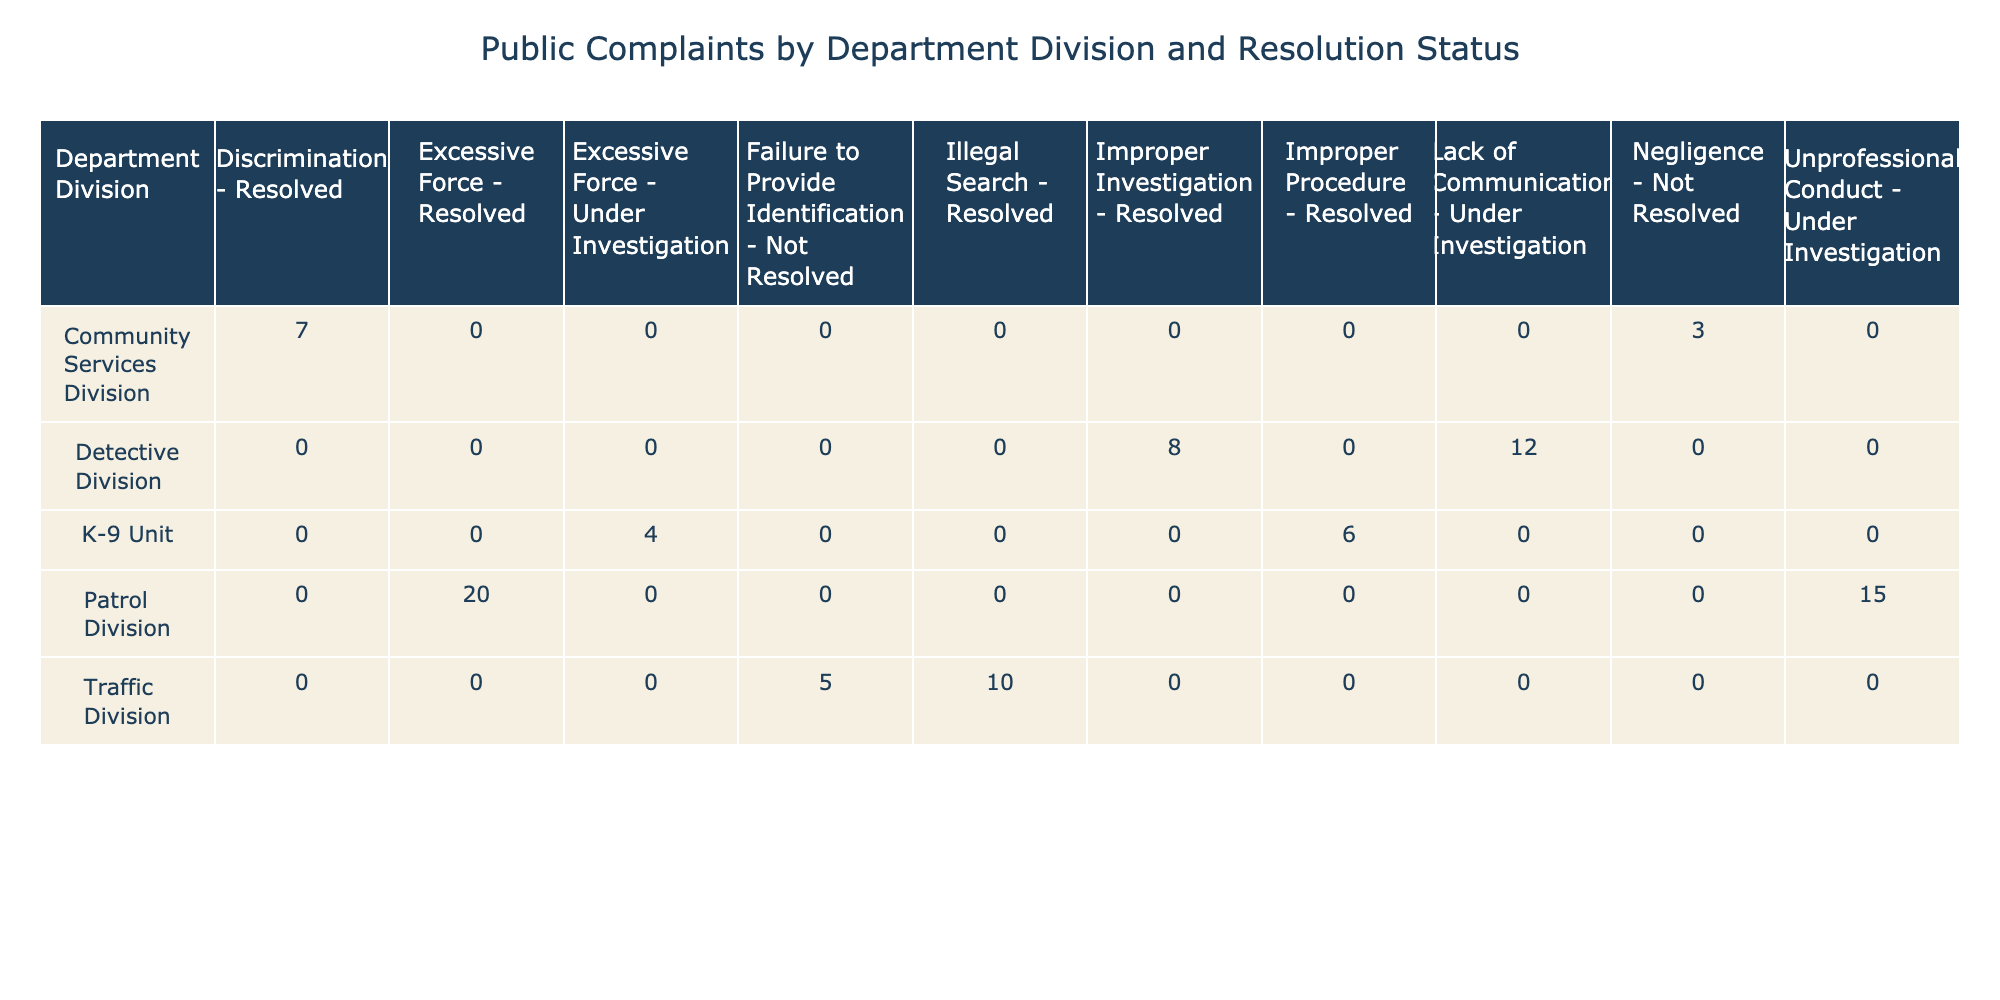What is the total number of resolved complaints in the Patrol Division? There are two categories in the Patrol Division: Excessive Force with 20 resolved complaints and Unprofessional Conduct which is under investigation. Thus, the total number of resolved complaints is 20.
Answer: 20 How many complaints in the Traffic Division are categorized as "Not Resolved"? In the Traffic Division, there is one complaint categorized as "Not Resolved" which is "Failure to Provide Identification," with a count of 5.
Answer: 5 Is there any complaint in the Community Services Division that is "Under Investigation"? The Community Services Division has two complaints: "Discrimination" is resolved, and "Negligence" is not resolved. Therefore, there are no complaints under investigation in this division.
Answer: No What is the sum of all complaints received by the K-9 Unit? The K-9 Unit has two complaints: Excessive Force with 4 counts and Improper Procedure with 6 counts. Therefore, the sum of all complaints is 4 + 6 = 10.
Answer: 10 Which division has the highest number of complaints that are "Under Investigation"? The Detective Division has a total of 12 complaints under investigation for the Lack of Communication. The K-9 Unit has 4 complaints under investigation for Excessive Force. Therefore, the Detective Division has the highest number of complaints under investigation.
Answer: Detective Division What is the total number of complaints that are resolved across all divisions? We sum all resolved complaints: Patrol Division 20 + Traffic Division 10 + Detective Division 8 + Community Services Division 7 + K-9 Unit 6 = 61 resolved complaints total.
Answer: 61 How many more complaints are there in the Patrol Division than in the Community Services Division? The Patrol Division has 35 complaints (20 resolved + 15 under investigation), and the Community Services Division has 10 complaints (7 resolved + 3 not resolved). Therefore, 35 - 10 = 25 more complaints in the Patrol Division.
Answer: 25 Are there more complaints categorized as "Improper Procedure" or "Excessive Force"? The table shows that there are 6 complaints for Improper Procedure and 24 complaints for Excessive Force (20 in Patrol and 4 in K-9). Since 24 > 6, there are more complaints for Excessive Force.
Answer: Yes What percentage of complaints in the Detective Division are resolved? In the Detective Division, there are 8 resolved complaints and 12 under investigation. The total complaints here are 8 + 12 = 20. The percentage resolved is (8/20) * 100 = 40%.
Answer: 40% 